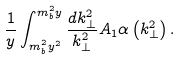Convert formula to latex. <formula><loc_0><loc_0><loc_500><loc_500>\frac { 1 } { y } \int _ { m _ { b } ^ { 2 } y ^ { 2 } } ^ { m _ { b } ^ { 2 } y } \frac { d k _ { \perp } ^ { 2 } } { k _ { \perp } ^ { 2 } } A _ { 1 } \alpha \left ( k _ { \perp } ^ { 2 } \right ) .</formula> 